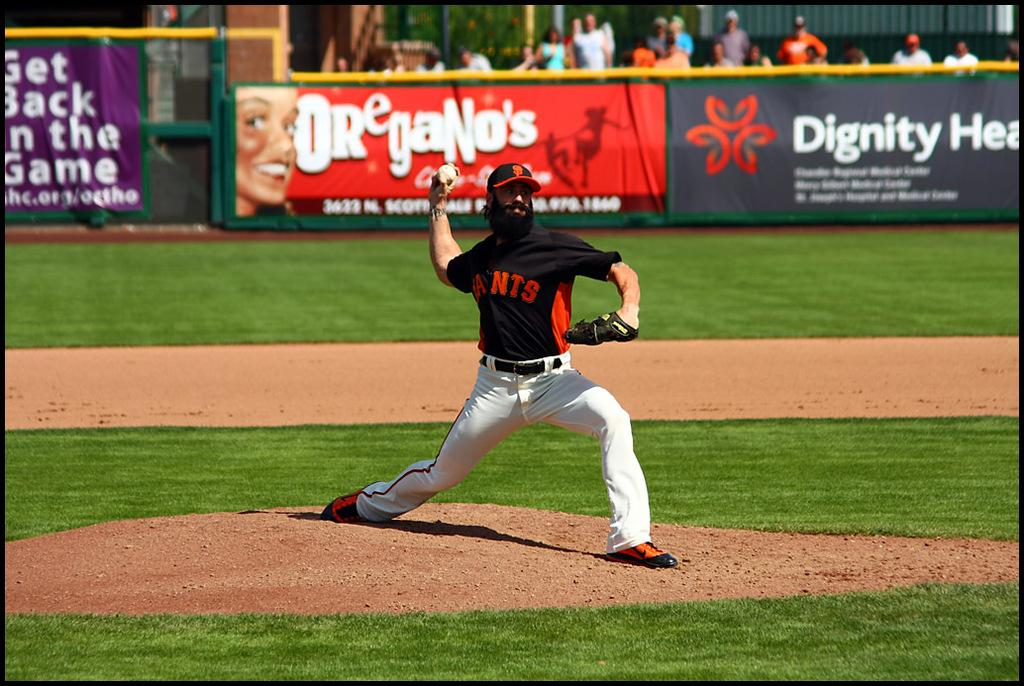<image>
Provide a brief description of the given image. a pitcher is in front of the term Oregano 